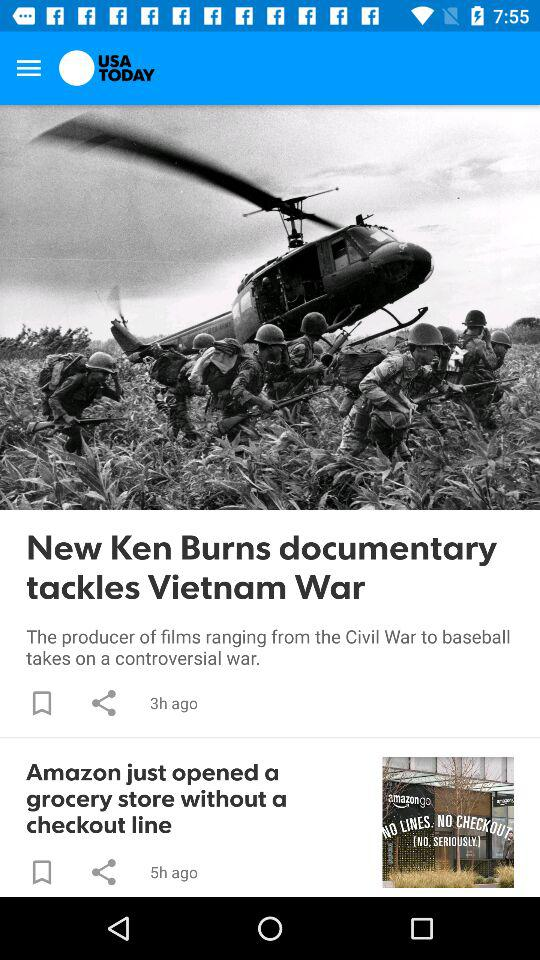How much longer ago was the last article published than the first?
Answer the question using a single word or phrase. 2 hours 